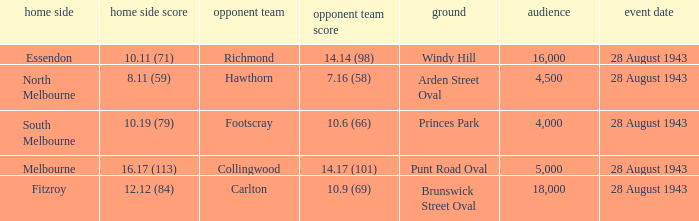Where was the game played with an away team score of 14.17 (101)? Punt Road Oval. 